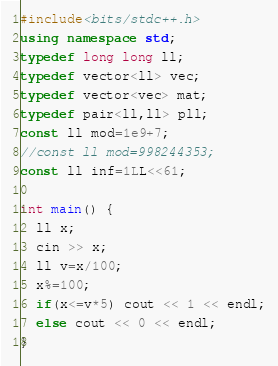<code> <loc_0><loc_0><loc_500><loc_500><_C++_>#include<bits/stdc++.h>
using namespace std;
typedef long long ll;
typedef vector<ll> vec;
typedef vector<vec> mat;
typedef pair<ll,ll> pll;
const ll mod=1e9+7;
//const ll mod=998244353;
const ll inf=1LL<<61;

int main() {
  ll x;
  cin >> x;
  ll v=x/100;
  x%=100;
  if(x<=v*5) cout << 1 << endl;
  else cout << 0 << endl;
}</code> 